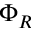<formula> <loc_0><loc_0><loc_500><loc_500>\Phi _ { R }</formula> 